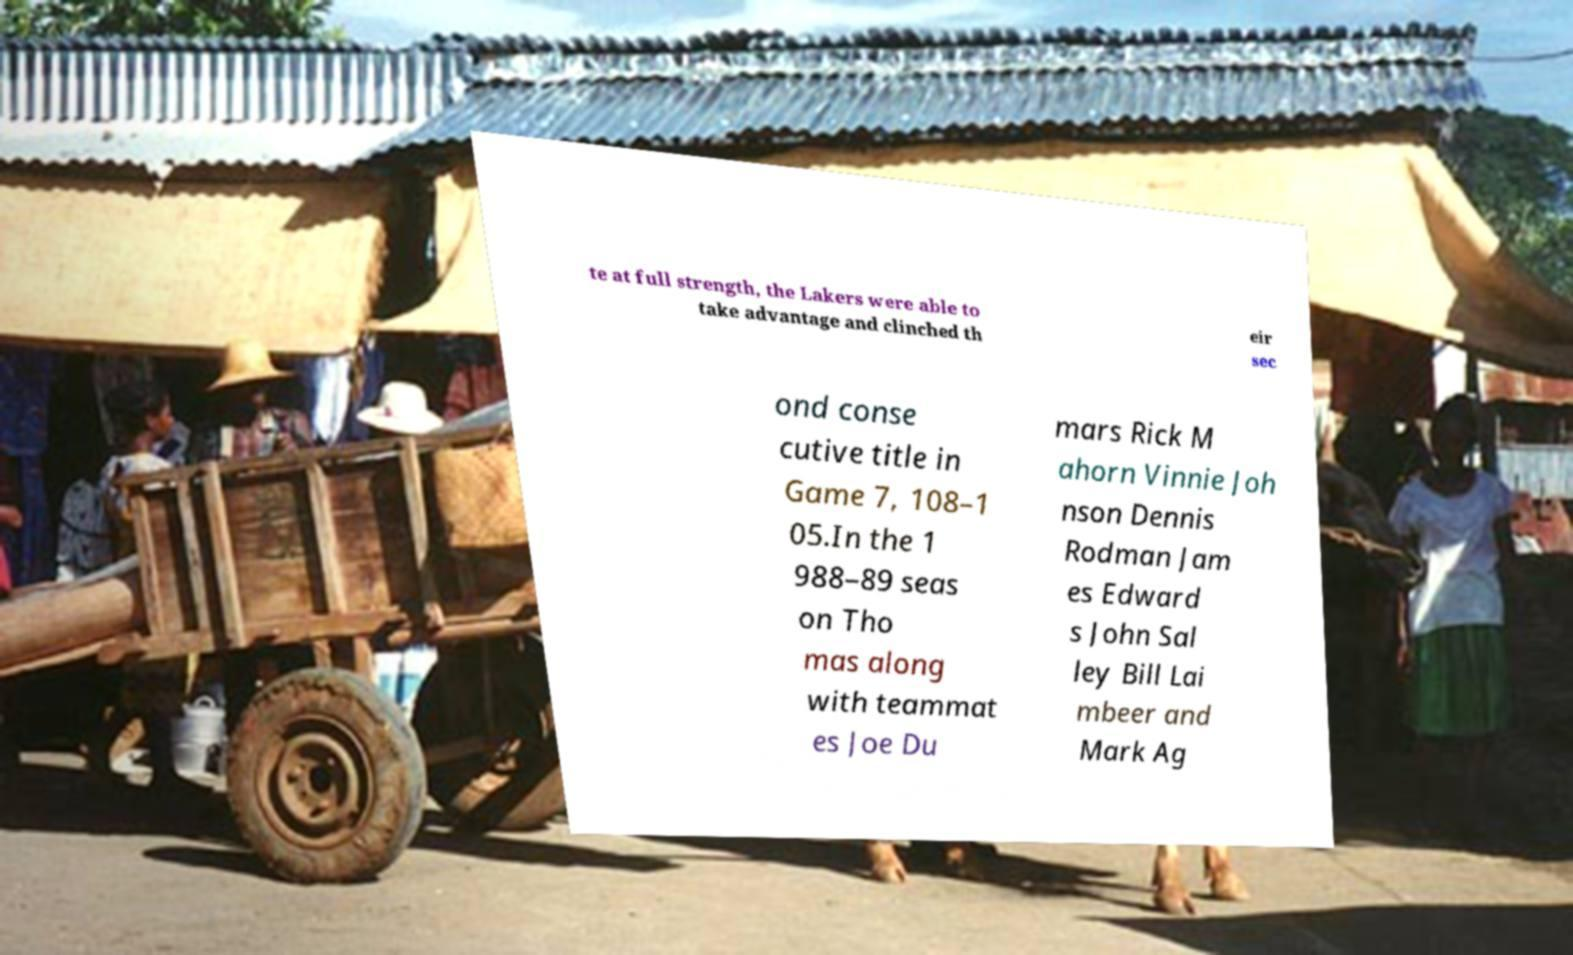Please identify and transcribe the text found in this image. te at full strength, the Lakers were able to take advantage and clinched th eir sec ond conse cutive title in Game 7, 108–1 05.In the 1 988–89 seas on Tho mas along with teammat es Joe Du mars Rick M ahorn Vinnie Joh nson Dennis Rodman Jam es Edward s John Sal ley Bill Lai mbeer and Mark Ag 